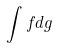<formula> <loc_0><loc_0><loc_500><loc_500>\int f d g</formula> 